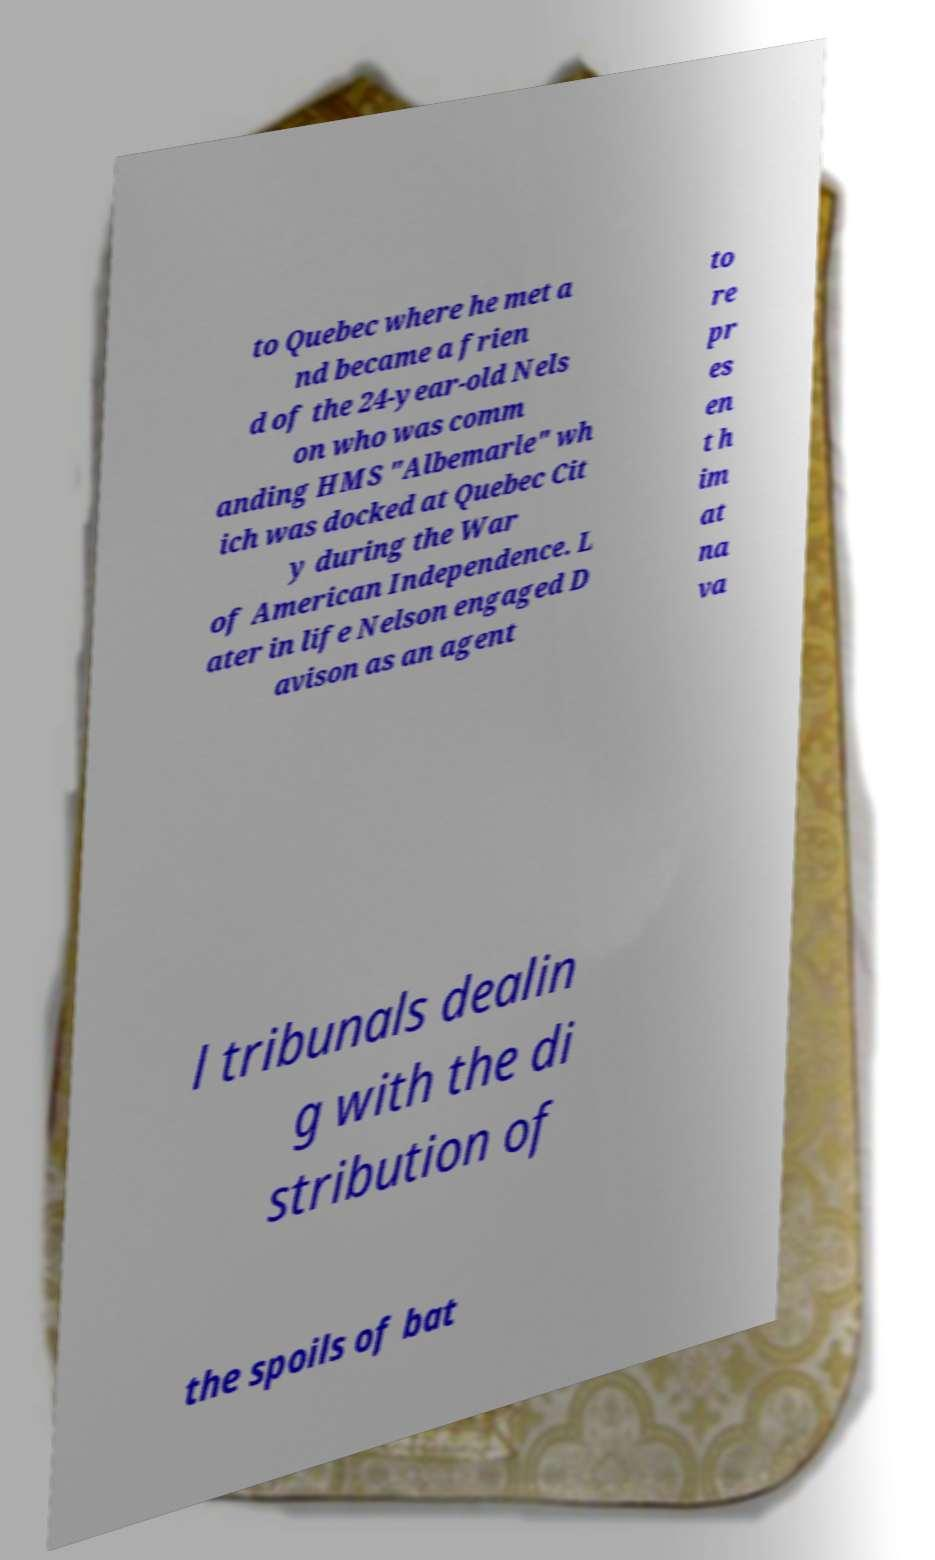For documentation purposes, I need the text within this image transcribed. Could you provide that? to Quebec where he met a nd became a frien d of the 24-year-old Nels on who was comm anding HMS "Albemarle" wh ich was docked at Quebec Cit y during the War of American Independence. L ater in life Nelson engaged D avison as an agent to re pr es en t h im at na va l tribunals dealin g with the di stribution of the spoils of bat 